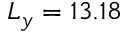<formula> <loc_0><loc_0><loc_500><loc_500>L _ { y } = 1 3 . 1 8</formula> 